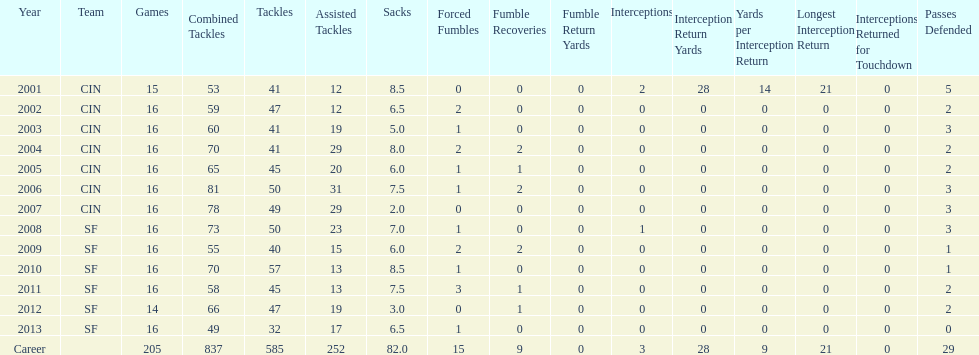What is the typical number of tackles this player has had during his career? 45. 